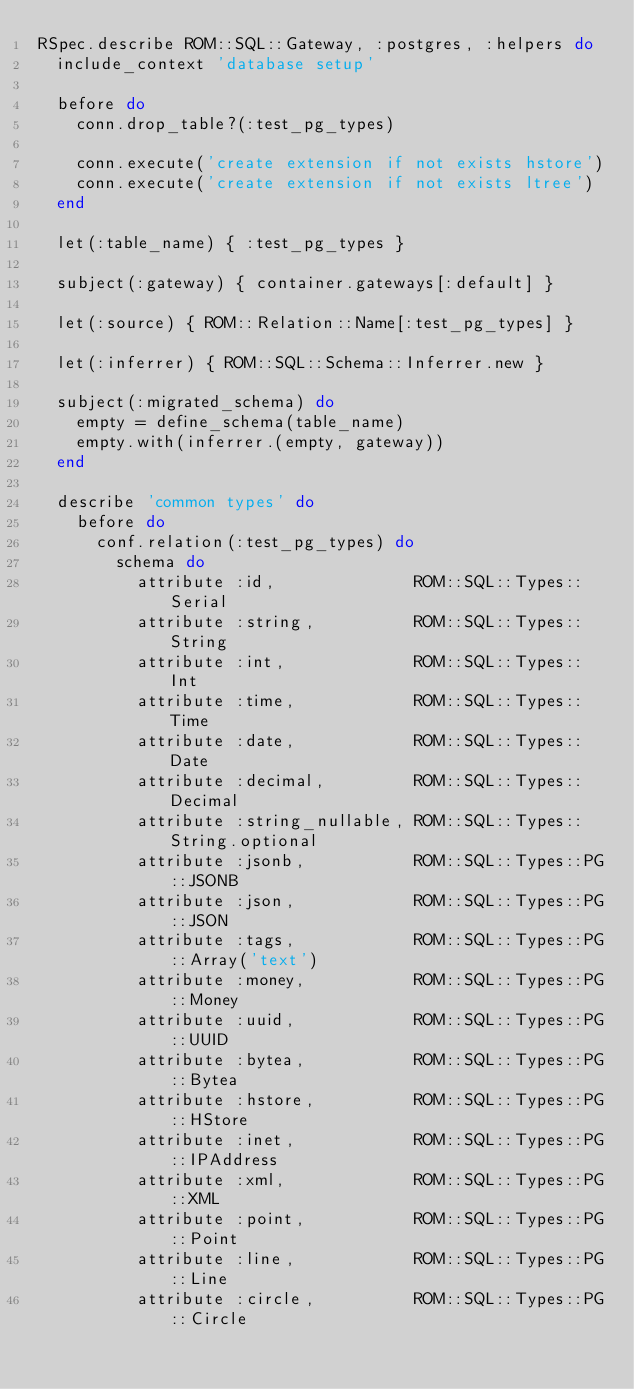Convert code to text. <code><loc_0><loc_0><loc_500><loc_500><_Ruby_>RSpec.describe ROM::SQL::Gateway, :postgres, :helpers do
  include_context 'database setup'

  before do
    conn.drop_table?(:test_pg_types)

    conn.execute('create extension if not exists hstore')
    conn.execute('create extension if not exists ltree')
  end

  let(:table_name) { :test_pg_types }

  subject(:gateway) { container.gateways[:default] }

  let(:source) { ROM::Relation::Name[:test_pg_types] }

  let(:inferrer) { ROM::SQL::Schema::Inferrer.new }

  subject(:migrated_schema) do
    empty = define_schema(table_name)
    empty.with(inferrer.(empty, gateway))
  end

  describe 'common types' do
    before do
      conf.relation(:test_pg_types) do
        schema do
          attribute :id,              ROM::SQL::Types::Serial
          attribute :string,          ROM::SQL::Types::String
          attribute :int,             ROM::SQL::Types::Int
          attribute :time,            ROM::SQL::Types::Time
          attribute :date,            ROM::SQL::Types::Date
          attribute :decimal,         ROM::SQL::Types::Decimal
          attribute :string_nullable, ROM::SQL::Types::String.optional
          attribute :jsonb,           ROM::SQL::Types::PG::JSONB
          attribute :json,            ROM::SQL::Types::PG::JSON
          attribute :tags,            ROM::SQL::Types::PG::Array('text')
          attribute :money,           ROM::SQL::Types::PG::Money
          attribute :uuid,            ROM::SQL::Types::PG::UUID
          attribute :bytea,           ROM::SQL::Types::PG::Bytea
          attribute :hstore,          ROM::SQL::Types::PG::HStore
          attribute :inet,            ROM::SQL::Types::PG::IPAddress
          attribute :xml,             ROM::SQL::Types::PG::XML
          attribute :point,           ROM::SQL::Types::PG::Point
          attribute :line,            ROM::SQL::Types::PG::Line
          attribute :circle,          ROM::SQL::Types::PG::Circle</code> 